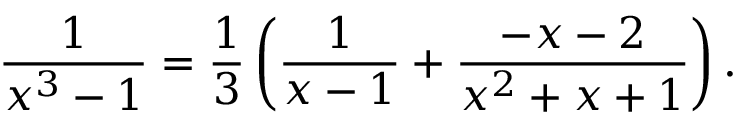<formula> <loc_0><loc_0><loc_500><loc_500>{ \frac { 1 } { x ^ { 3 } - 1 } } = { \frac { 1 } { 3 } } \left ( { \frac { 1 } { x - 1 } } + { \frac { - x - 2 } { x ^ { 2 } + x + 1 } } \right ) .</formula> 